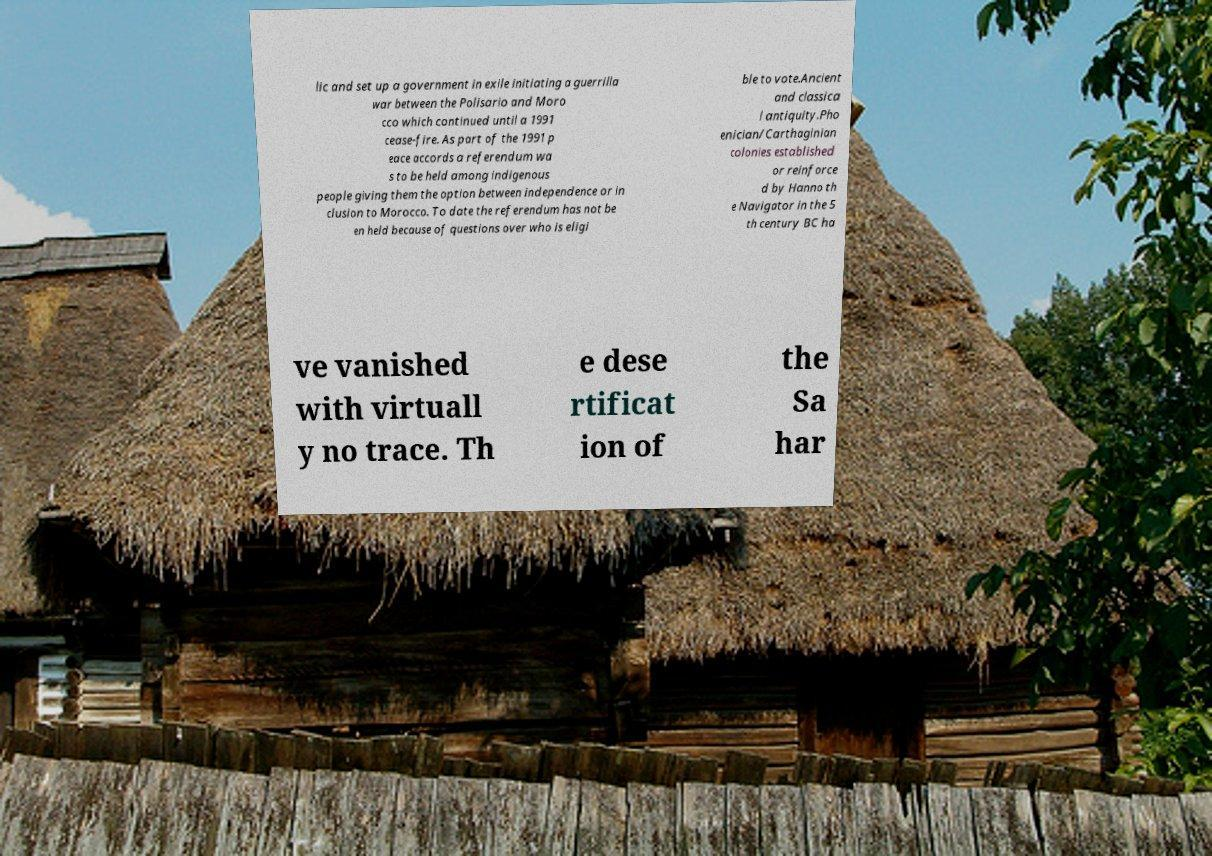Can you accurately transcribe the text from the provided image for me? lic and set up a government in exile initiating a guerrilla war between the Polisario and Moro cco which continued until a 1991 cease-fire. As part of the 1991 p eace accords a referendum wa s to be held among indigenous people giving them the option between independence or in clusion to Morocco. To date the referendum has not be en held because of questions over who is eligi ble to vote.Ancient and classica l antiquity.Pho enician/Carthaginian colonies established or reinforce d by Hanno th e Navigator in the 5 th century BC ha ve vanished with virtuall y no trace. Th e dese rtificat ion of the Sa har 